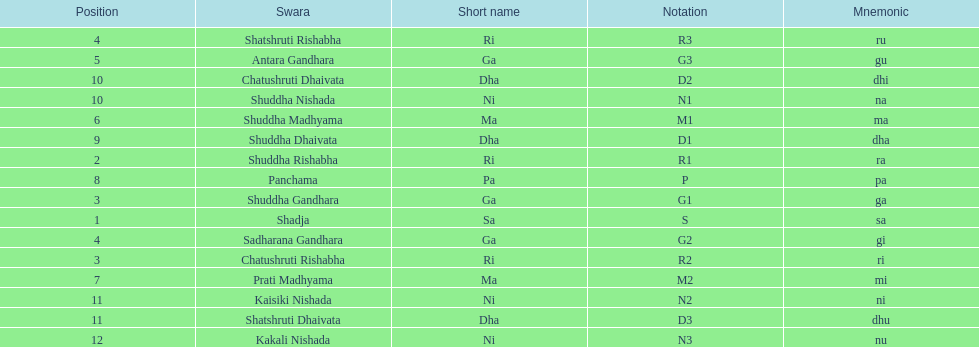On average how many of the swara have a short name that begin with d or g? 6. 